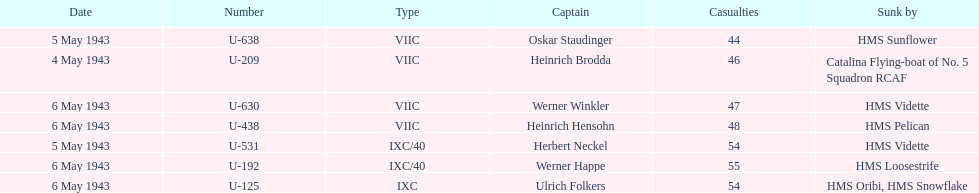What was the only captain sunk by hms pelican? Heinrich Hensohn. 